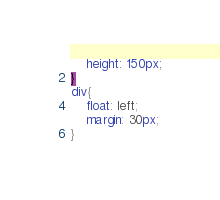<code> <loc_0><loc_0><loc_500><loc_500><_CSS_>    height: 150px;
}
div{
    float: left;
    margin: 30px;
}</code> 